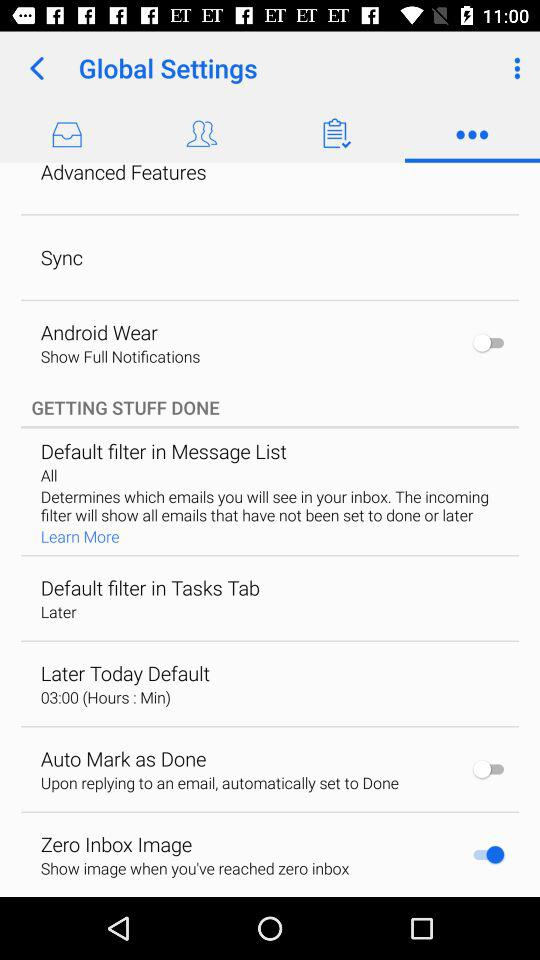What is the description for "Auto Mark as Done"? The description is "Upon replying to an email, automatically set to Done". 